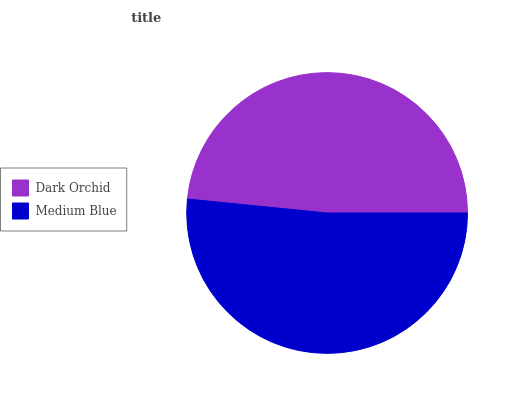Is Dark Orchid the minimum?
Answer yes or no. Yes. Is Medium Blue the maximum?
Answer yes or no. Yes. Is Medium Blue the minimum?
Answer yes or no. No. Is Medium Blue greater than Dark Orchid?
Answer yes or no. Yes. Is Dark Orchid less than Medium Blue?
Answer yes or no. Yes. Is Dark Orchid greater than Medium Blue?
Answer yes or no. No. Is Medium Blue less than Dark Orchid?
Answer yes or no. No. Is Medium Blue the high median?
Answer yes or no. Yes. Is Dark Orchid the low median?
Answer yes or no. Yes. Is Dark Orchid the high median?
Answer yes or no. No. Is Medium Blue the low median?
Answer yes or no. No. 